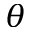<formula> <loc_0><loc_0><loc_500><loc_500>\theta</formula> 